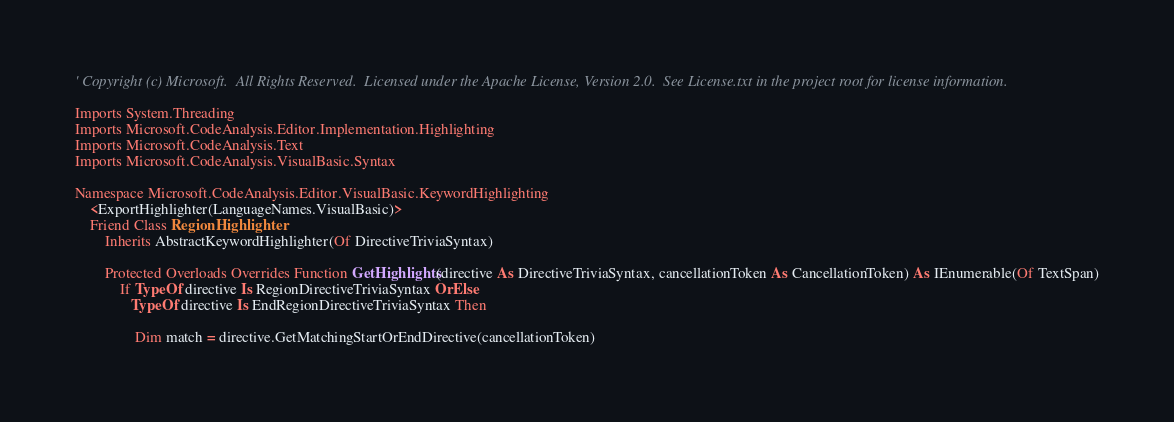<code> <loc_0><loc_0><loc_500><loc_500><_VisualBasic_>' Copyright (c) Microsoft.  All Rights Reserved.  Licensed under the Apache License, Version 2.0.  See License.txt in the project root for license information.

Imports System.Threading
Imports Microsoft.CodeAnalysis.Editor.Implementation.Highlighting
Imports Microsoft.CodeAnalysis.Text
Imports Microsoft.CodeAnalysis.VisualBasic.Syntax

Namespace Microsoft.CodeAnalysis.Editor.VisualBasic.KeywordHighlighting
    <ExportHighlighter(LanguageNames.VisualBasic)>
    Friend Class RegionHighlighter
        Inherits AbstractKeywordHighlighter(Of DirectiveTriviaSyntax)

        Protected Overloads Overrides Function GetHighlights(directive As DirectiveTriviaSyntax, cancellationToken As CancellationToken) As IEnumerable(Of TextSpan)
            If TypeOf directive Is RegionDirectiveTriviaSyntax OrElse
               TypeOf directive Is EndRegionDirectiveTriviaSyntax Then

                Dim match = directive.GetMatchingStartOrEndDirective(cancellationToken)</code> 